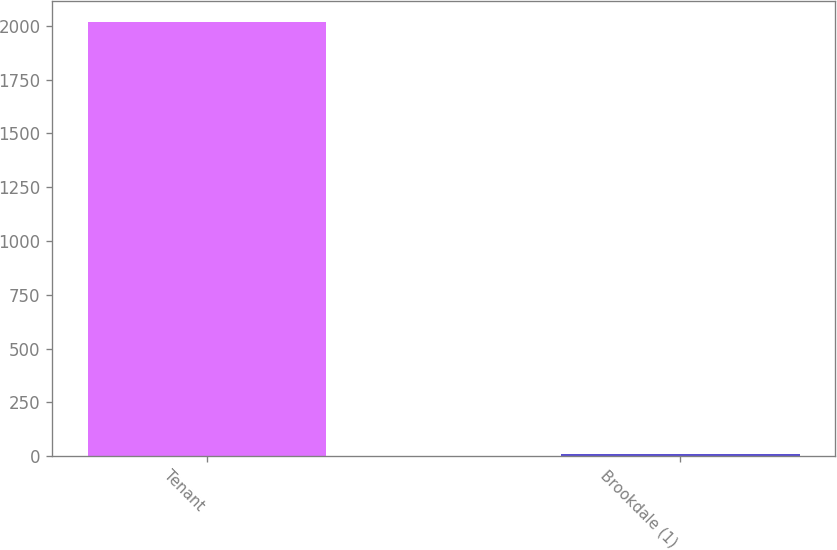Convert chart. <chart><loc_0><loc_0><loc_500><loc_500><bar_chart><fcel>Tenant<fcel>Brookdale (1)<nl><fcel>2017<fcel>8<nl></chart> 